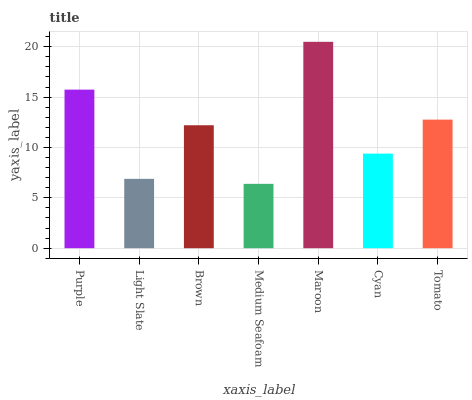Is Medium Seafoam the minimum?
Answer yes or no. Yes. Is Maroon the maximum?
Answer yes or no. Yes. Is Light Slate the minimum?
Answer yes or no. No. Is Light Slate the maximum?
Answer yes or no. No. Is Purple greater than Light Slate?
Answer yes or no. Yes. Is Light Slate less than Purple?
Answer yes or no. Yes. Is Light Slate greater than Purple?
Answer yes or no. No. Is Purple less than Light Slate?
Answer yes or no. No. Is Brown the high median?
Answer yes or no. Yes. Is Brown the low median?
Answer yes or no. Yes. Is Tomato the high median?
Answer yes or no. No. Is Purple the low median?
Answer yes or no. No. 